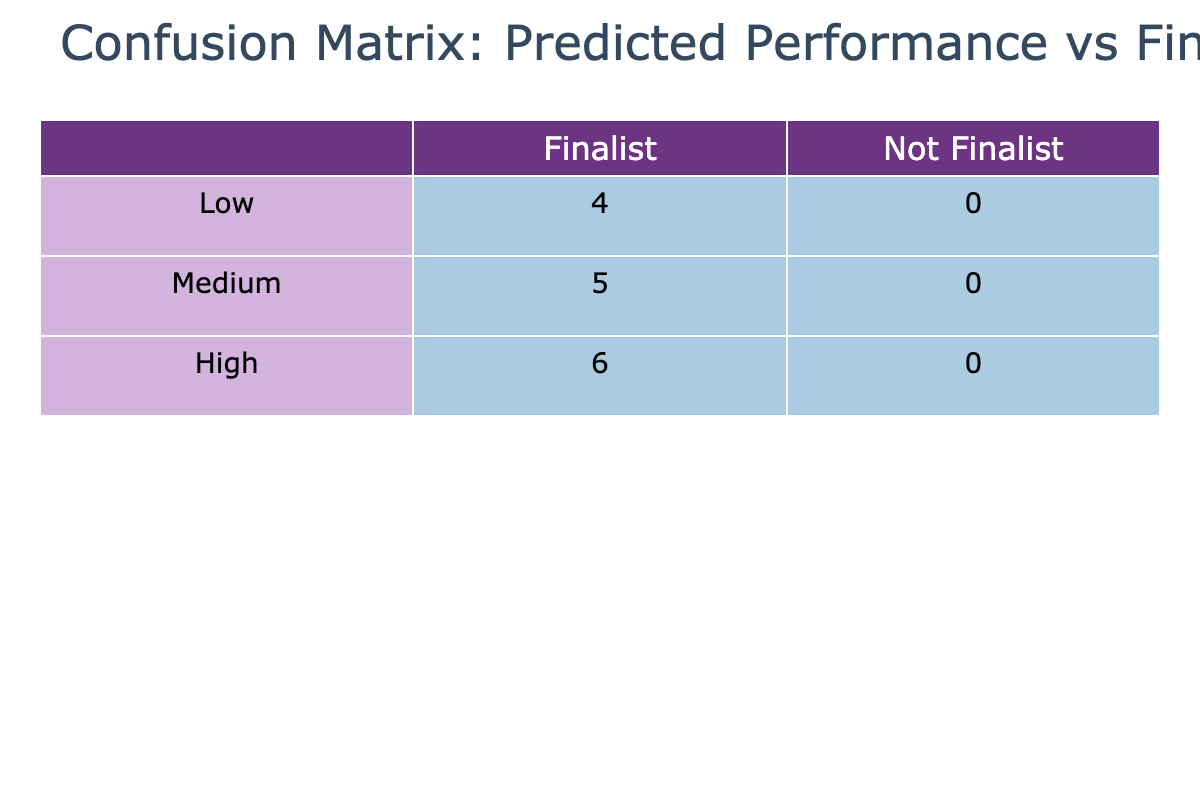What is the total number of predicted 'High' performances? In the table, we count how many times 'High' appears in the 'Predicted Performance' column. There are 6 occurrences of 'High'.
Answer: 6 How many finalists were predicted to have 'Low' performance? Looking at the 'Finalist Status' column for 'Low' in the 'Predicted Performance' row, 'Low' has 1 associated True value (True).
Answer: 1 What is the difference in the number of 'Medium' predicted performances between finalists and non-finalists? For 'Medium', there are 3 True (finalists) and 2 False (non-finalists). The difference is 3 - 2 = 1.
Answer: 1 Did any 'Low' predicted performances classify as finalists? There is 1 instance of 'Low' in the 'Finalist Status' column that is True, meaning there is at least 1 'Low' performance that was a finalist.
Answer: Yes Which predicted performance category had the highest number of finalists? By evaluating the finalist counts: 'High' has 5, 'Medium' has 3, and 'Low' has 1. The highest number of finalists is found in the 'High' category with 5.
Answer: High What percentage of 'High' predicted performances were indeed finalists? To find the percentage, divide the number of 'High' finalists (5) by all 'High' predictions (6) and multiply by 100: (5/6) * 100 = 83.33%.
Answer: 83.33% How many times did 'Medium' predicted performances accord with not being a finalist? From the table, we note 'Medium' has 2 instances associated with the non-finalist status (False).
Answer: 2 What is the average number of finalists across the performance categories? Counting finalists: 'High' has 5, 'Medium' has 3, and 'Low' has 1. So, the average = (5 + 3 + 1) / 3 = 3.
Answer: 3 Was the predicted performance accurate for all of the finalists? By checking, there were 5 'High', 3 'Medium', and 1 'Low' as finalists. Since finalist predictions include only 'High' and 'Medium', the answer is no; not all predictions were correct.
Answer: No How does the number of 'Not Finalists' predicted as 'Low' compare to those predicted as 'Medium'? For 'Low', there are 2 non-finalists and for 'Medium', there are 2 non-finalists as well. The comparison shows they are equal: 2 each.
Answer: Equal 